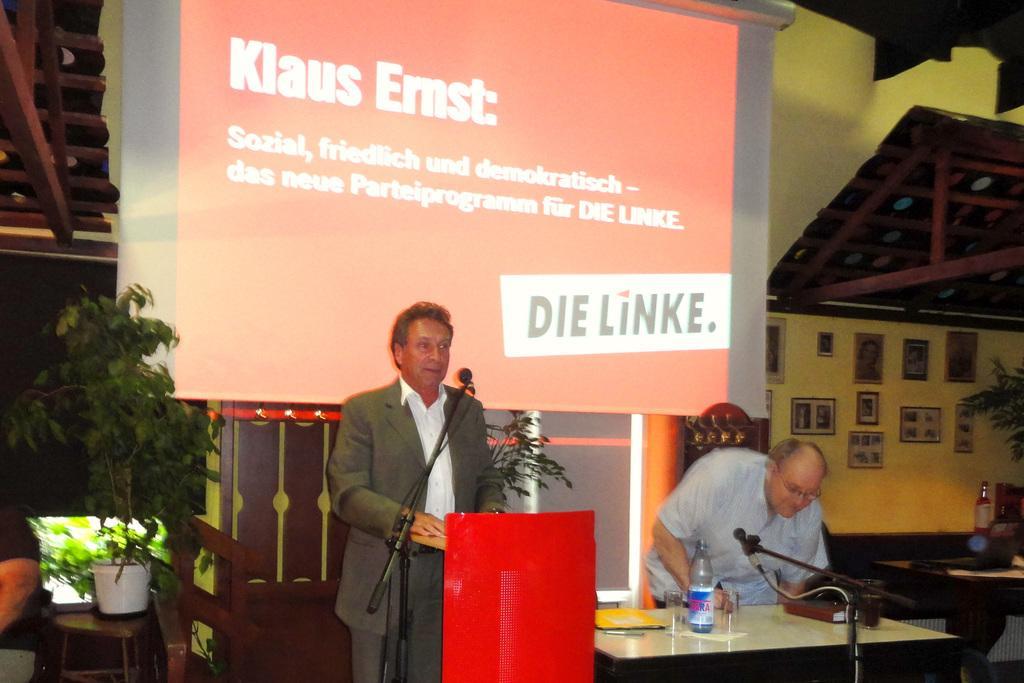Can you describe this image briefly? a person is standing wearing a suit. in front of him there is a microphone and a it's wooden table which is red in color. at the right there is a table on which there is a bottle, microphone and a book. behind that a person is standing. at the back there is a projector display which is red in color. at the left there is a plant on a table. at the right there is a table and at the back there is a wall on which there are photo frames. 